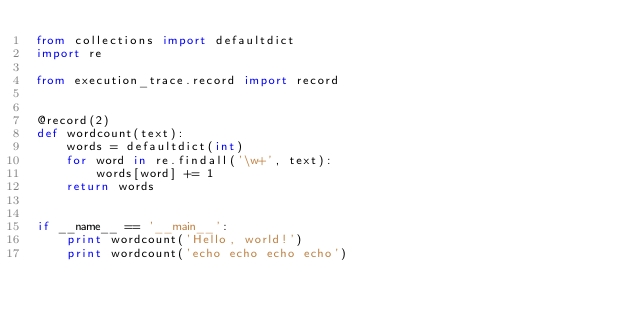<code> <loc_0><loc_0><loc_500><loc_500><_Python_>from collections import defaultdict
import re

from execution_trace.record import record


@record(2)
def wordcount(text):
    words = defaultdict(int)
    for word in re.findall('\w+', text):
        words[word] += 1
    return words


if __name__ == '__main__':
    print wordcount('Hello, world!')
    print wordcount('echo echo echo echo')

</code> 